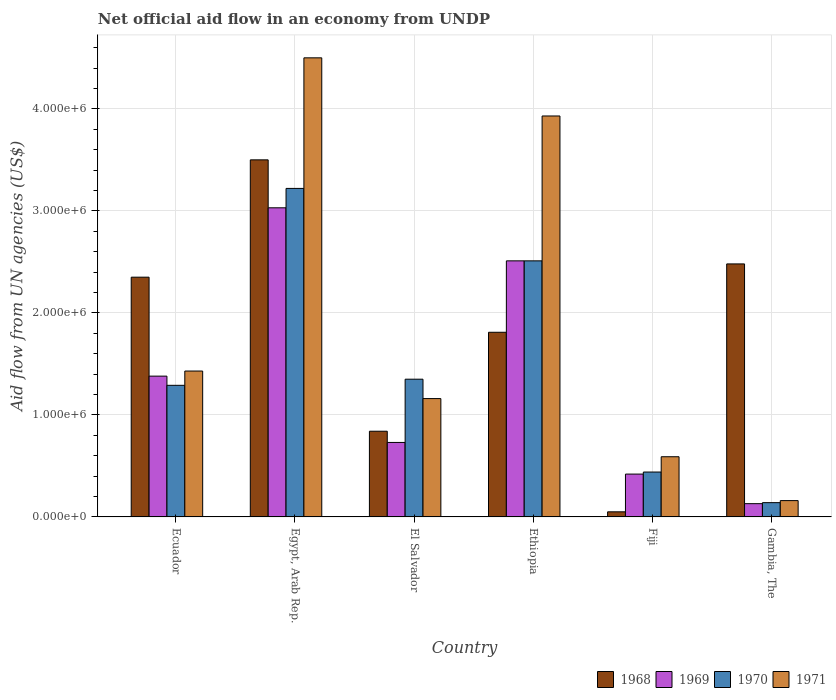How many different coloured bars are there?
Your answer should be compact. 4. How many groups of bars are there?
Keep it short and to the point. 6. Are the number of bars on each tick of the X-axis equal?
Keep it short and to the point. Yes. How many bars are there on the 1st tick from the left?
Keep it short and to the point. 4. What is the label of the 6th group of bars from the left?
Provide a short and direct response. Gambia, The. In how many cases, is the number of bars for a given country not equal to the number of legend labels?
Your answer should be compact. 0. What is the net official aid flow in 1970 in El Salvador?
Provide a succinct answer. 1.35e+06. Across all countries, what is the maximum net official aid flow in 1969?
Give a very brief answer. 3.03e+06. In which country was the net official aid flow in 1970 maximum?
Your response must be concise. Egypt, Arab Rep. In which country was the net official aid flow in 1969 minimum?
Keep it short and to the point. Gambia, The. What is the total net official aid flow in 1971 in the graph?
Your response must be concise. 1.18e+07. What is the difference between the net official aid flow in 1968 in Ecuador and that in El Salvador?
Offer a very short reply. 1.51e+06. What is the average net official aid flow in 1969 per country?
Provide a short and direct response. 1.37e+06. What is the difference between the net official aid flow of/in 1971 and net official aid flow of/in 1970 in Fiji?
Make the answer very short. 1.50e+05. In how many countries, is the net official aid flow in 1969 greater than 4000000 US$?
Make the answer very short. 0. What is the ratio of the net official aid flow in 1970 in El Salvador to that in Fiji?
Offer a terse response. 3.07. Is the net official aid flow in 1971 in Ecuador less than that in Gambia, The?
Give a very brief answer. No. What is the difference between the highest and the second highest net official aid flow in 1968?
Keep it short and to the point. 1.02e+06. What is the difference between the highest and the lowest net official aid flow in 1971?
Provide a succinct answer. 4.34e+06. In how many countries, is the net official aid flow in 1968 greater than the average net official aid flow in 1968 taken over all countries?
Provide a short and direct response. 3. Is the sum of the net official aid flow in 1969 in Ethiopia and Fiji greater than the maximum net official aid flow in 1968 across all countries?
Make the answer very short. No. Is it the case that in every country, the sum of the net official aid flow in 1968 and net official aid flow in 1970 is greater than the sum of net official aid flow in 1969 and net official aid flow in 1971?
Offer a very short reply. No. What does the 1st bar from the left in Gambia, The represents?
Offer a terse response. 1968. What does the 1st bar from the right in Ecuador represents?
Your answer should be very brief. 1971. Is it the case that in every country, the sum of the net official aid flow in 1968 and net official aid flow in 1969 is greater than the net official aid flow in 1970?
Make the answer very short. Yes. Does the graph contain grids?
Keep it short and to the point. Yes. What is the title of the graph?
Offer a very short reply. Net official aid flow in an economy from UNDP. What is the label or title of the X-axis?
Ensure brevity in your answer.  Country. What is the label or title of the Y-axis?
Provide a short and direct response. Aid flow from UN agencies (US$). What is the Aid flow from UN agencies (US$) of 1968 in Ecuador?
Ensure brevity in your answer.  2.35e+06. What is the Aid flow from UN agencies (US$) of 1969 in Ecuador?
Provide a succinct answer. 1.38e+06. What is the Aid flow from UN agencies (US$) of 1970 in Ecuador?
Offer a terse response. 1.29e+06. What is the Aid flow from UN agencies (US$) in 1971 in Ecuador?
Offer a very short reply. 1.43e+06. What is the Aid flow from UN agencies (US$) of 1968 in Egypt, Arab Rep.?
Your answer should be compact. 3.50e+06. What is the Aid flow from UN agencies (US$) of 1969 in Egypt, Arab Rep.?
Offer a very short reply. 3.03e+06. What is the Aid flow from UN agencies (US$) in 1970 in Egypt, Arab Rep.?
Your answer should be very brief. 3.22e+06. What is the Aid flow from UN agencies (US$) of 1971 in Egypt, Arab Rep.?
Offer a very short reply. 4.50e+06. What is the Aid flow from UN agencies (US$) in 1968 in El Salvador?
Offer a very short reply. 8.40e+05. What is the Aid flow from UN agencies (US$) in 1969 in El Salvador?
Keep it short and to the point. 7.30e+05. What is the Aid flow from UN agencies (US$) of 1970 in El Salvador?
Provide a short and direct response. 1.35e+06. What is the Aid flow from UN agencies (US$) of 1971 in El Salvador?
Your response must be concise. 1.16e+06. What is the Aid flow from UN agencies (US$) in 1968 in Ethiopia?
Ensure brevity in your answer.  1.81e+06. What is the Aid flow from UN agencies (US$) in 1969 in Ethiopia?
Provide a short and direct response. 2.51e+06. What is the Aid flow from UN agencies (US$) of 1970 in Ethiopia?
Make the answer very short. 2.51e+06. What is the Aid flow from UN agencies (US$) in 1971 in Ethiopia?
Offer a very short reply. 3.93e+06. What is the Aid flow from UN agencies (US$) of 1968 in Fiji?
Your answer should be compact. 5.00e+04. What is the Aid flow from UN agencies (US$) of 1969 in Fiji?
Offer a terse response. 4.20e+05. What is the Aid flow from UN agencies (US$) in 1971 in Fiji?
Offer a very short reply. 5.90e+05. What is the Aid flow from UN agencies (US$) of 1968 in Gambia, The?
Ensure brevity in your answer.  2.48e+06. What is the Aid flow from UN agencies (US$) in 1969 in Gambia, The?
Give a very brief answer. 1.30e+05. What is the Aid flow from UN agencies (US$) of 1970 in Gambia, The?
Offer a terse response. 1.40e+05. Across all countries, what is the maximum Aid flow from UN agencies (US$) in 1968?
Your answer should be compact. 3.50e+06. Across all countries, what is the maximum Aid flow from UN agencies (US$) of 1969?
Offer a very short reply. 3.03e+06. Across all countries, what is the maximum Aid flow from UN agencies (US$) of 1970?
Offer a terse response. 3.22e+06. Across all countries, what is the maximum Aid flow from UN agencies (US$) in 1971?
Give a very brief answer. 4.50e+06. Across all countries, what is the minimum Aid flow from UN agencies (US$) in 1968?
Your answer should be compact. 5.00e+04. Across all countries, what is the minimum Aid flow from UN agencies (US$) of 1970?
Your answer should be very brief. 1.40e+05. Across all countries, what is the minimum Aid flow from UN agencies (US$) in 1971?
Provide a short and direct response. 1.60e+05. What is the total Aid flow from UN agencies (US$) in 1968 in the graph?
Your answer should be very brief. 1.10e+07. What is the total Aid flow from UN agencies (US$) in 1969 in the graph?
Offer a very short reply. 8.20e+06. What is the total Aid flow from UN agencies (US$) in 1970 in the graph?
Your answer should be compact. 8.95e+06. What is the total Aid flow from UN agencies (US$) in 1971 in the graph?
Ensure brevity in your answer.  1.18e+07. What is the difference between the Aid flow from UN agencies (US$) in 1968 in Ecuador and that in Egypt, Arab Rep.?
Your answer should be compact. -1.15e+06. What is the difference between the Aid flow from UN agencies (US$) in 1969 in Ecuador and that in Egypt, Arab Rep.?
Ensure brevity in your answer.  -1.65e+06. What is the difference between the Aid flow from UN agencies (US$) of 1970 in Ecuador and that in Egypt, Arab Rep.?
Make the answer very short. -1.93e+06. What is the difference between the Aid flow from UN agencies (US$) in 1971 in Ecuador and that in Egypt, Arab Rep.?
Keep it short and to the point. -3.07e+06. What is the difference between the Aid flow from UN agencies (US$) in 1968 in Ecuador and that in El Salvador?
Give a very brief answer. 1.51e+06. What is the difference between the Aid flow from UN agencies (US$) in 1969 in Ecuador and that in El Salvador?
Offer a terse response. 6.50e+05. What is the difference between the Aid flow from UN agencies (US$) of 1970 in Ecuador and that in El Salvador?
Your answer should be very brief. -6.00e+04. What is the difference between the Aid flow from UN agencies (US$) of 1968 in Ecuador and that in Ethiopia?
Make the answer very short. 5.40e+05. What is the difference between the Aid flow from UN agencies (US$) of 1969 in Ecuador and that in Ethiopia?
Keep it short and to the point. -1.13e+06. What is the difference between the Aid flow from UN agencies (US$) of 1970 in Ecuador and that in Ethiopia?
Give a very brief answer. -1.22e+06. What is the difference between the Aid flow from UN agencies (US$) of 1971 in Ecuador and that in Ethiopia?
Offer a very short reply. -2.50e+06. What is the difference between the Aid flow from UN agencies (US$) of 1968 in Ecuador and that in Fiji?
Provide a short and direct response. 2.30e+06. What is the difference between the Aid flow from UN agencies (US$) of 1969 in Ecuador and that in Fiji?
Your answer should be compact. 9.60e+05. What is the difference between the Aid flow from UN agencies (US$) in 1970 in Ecuador and that in Fiji?
Your response must be concise. 8.50e+05. What is the difference between the Aid flow from UN agencies (US$) of 1971 in Ecuador and that in Fiji?
Offer a terse response. 8.40e+05. What is the difference between the Aid flow from UN agencies (US$) of 1969 in Ecuador and that in Gambia, The?
Your answer should be very brief. 1.25e+06. What is the difference between the Aid flow from UN agencies (US$) in 1970 in Ecuador and that in Gambia, The?
Provide a short and direct response. 1.15e+06. What is the difference between the Aid flow from UN agencies (US$) of 1971 in Ecuador and that in Gambia, The?
Make the answer very short. 1.27e+06. What is the difference between the Aid flow from UN agencies (US$) of 1968 in Egypt, Arab Rep. and that in El Salvador?
Your answer should be very brief. 2.66e+06. What is the difference between the Aid flow from UN agencies (US$) in 1969 in Egypt, Arab Rep. and that in El Salvador?
Provide a succinct answer. 2.30e+06. What is the difference between the Aid flow from UN agencies (US$) in 1970 in Egypt, Arab Rep. and that in El Salvador?
Keep it short and to the point. 1.87e+06. What is the difference between the Aid flow from UN agencies (US$) in 1971 in Egypt, Arab Rep. and that in El Salvador?
Offer a terse response. 3.34e+06. What is the difference between the Aid flow from UN agencies (US$) of 1968 in Egypt, Arab Rep. and that in Ethiopia?
Offer a very short reply. 1.69e+06. What is the difference between the Aid flow from UN agencies (US$) of 1969 in Egypt, Arab Rep. and that in Ethiopia?
Give a very brief answer. 5.20e+05. What is the difference between the Aid flow from UN agencies (US$) of 1970 in Egypt, Arab Rep. and that in Ethiopia?
Provide a short and direct response. 7.10e+05. What is the difference between the Aid flow from UN agencies (US$) in 1971 in Egypt, Arab Rep. and that in Ethiopia?
Provide a succinct answer. 5.70e+05. What is the difference between the Aid flow from UN agencies (US$) of 1968 in Egypt, Arab Rep. and that in Fiji?
Offer a terse response. 3.45e+06. What is the difference between the Aid flow from UN agencies (US$) of 1969 in Egypt, Arab Rep. and that in Fiji?
Offer a very short reply. 2.61e+06. What is the difference between the Aid flow from UN agencies (US$) in 1970 in Egypt, Arab Rep. and that in Fiji?
Your answer should be very brief. 2.78e+06. What is the difference between the Aid flow from UN agencies (US$) in 1971 in Egypt, Arab Rep. and that in Fiji?
Ensure brevity in your answer.  3.91e+06. What is the difference between the Aid flow from UN agencies (US$) of 1968 in Egypt, Arab Rep. and that in Gambia, The?
Keep it short and to the point. 1.02e+06. What is the difference between the Aid flow from UN agencies (US$) in 1969 in Egypt, Arab Rep. and that in Gambia, The?
Provide a short and direct response. 2.90e+06. What is the difference between the Aid flow from UN agencies (US$) in 1970 in Egypt, Arab Rep. and that in Gambia, The?
Keep it short and to the point. 3.08e+06. What is the difference between the Aid flow from UN agencies (US$) of 1971 in Egypt, Arab Rep. and that in Gambia, The?
Your answer should be compact. 4.34e+06. What is the difference between the Aid flow from UN agencies (US$) in 1968 in El Salvador and that in Ethiopia?
Give a very brief answer. -9.70e+05. What is the difference between the Aid flow from UN agencies (US$) of 1969 in El Salvador and that in Ethiopia?
Offer a terse response. -1.78e+06. What is the difference between the Aid flow from UN agencies (US$) in 1970 in El Salvador and that in Ethiopia?
Your answer should be compact. -1.16e+06. What is the difference between the Aid flow from UN agencies (US$) in 1971 in El Salvador and that in Ethiopia?
Your answer should be very brief. -2.77e+06. What is the difference between the Aid flow from UN agencies (US$) of 1968 in El Salvador and that in Fiji?
Provide a succinct answer. 7.90e+05. What is the difference between the Aid flow from UN agencies (US$) in 1969 in El Salvador and that in Fiji?
Make the answer very short. 3.10e+05. What is the difference between the Aid flow from UN agencies (US$) of 1970 in El Salvador and that in Fiji?
Give a very brief answer. 9.10e+05. What is the difference between the Aid flow from UN agencies (US$) of 1971 in El Salvador and that in Fiji?
Offer a very short reply. 5.70e+05. What is the difference between the Aid flow from UN agencies (US$) in 1968 in El Salvador and that in Gambia, The?
Your answer should be very brief. -1.64e+06. What is the difference between the Aid flow from UN agencies (US$) in 1969 in El Salvador and that in Gambia, The?
Provide a short and direct response. 6.00e+05. What is the difference between the Aid flow from UN agencies (US$) of 1970 in El Salvador and that in Gambia, The?
Provide a succinct answer. 1.21e+06. What is the difference between the Aid flow from UN agencies (US$) of 1968 in Ethiopia and that in Fiji?
Ensure brevity in your answer.  1.76e+06. What is the difference between the Aid flow from UN agencies (US$) in 1969 in Ethiopia and that in Fiji?
Offer a terse response. 2.09e+06. What is the difference between the Aid flow from UN agencies (US$) in 1970 in Ethiopia and that in Fiji?
Offer a very short reply. 2.07e+06. What is the difference between the Aid flow from UN agencies (US$) of 1971 in Ethiopia and that in Fiji?
Your answer should be compact. 3.34e+06. What is the difference between the Aid flow from UN agencies (US$) of 1968 in Ethiopia and that in Gambia, The?
Your response must be concise. -6.70e+05. What is the difference between the Aid flow from UN agencies (US$) in 1969 in Ethiopia and that in Gambia, The?
Give a very brief answer. 2.38e+06. What is the difference between the Aid flow from UN agencies (US$) in 1970 in Ethiopia and that in Gambia, The?
Provide a succinct answer. 2.37e+06. What is the difference between the Aid flow from UN agencies (US$) of 1971 in Ethiopia and that in Gambia, The?
Your answer should be very brief. 3.77e+06. What is the difference between the Aid flow from UN agencies (US$) in 1968 in Fiji and that in Gambia, The?
Your answer should be compact. -2.43e+06. What is the difference between the Aid flow from UN agencies (US$) in 1971 in Fiji and that in Gambia, The?
Keep it short and to the point. 4.30e+05. What is the difference between the Aid flow from UN agencies (US$) of 1968 in Ecuador and the Aid flow from UN agencies (US$) of 1969 in Egypt, Arab Rep.?
Your response must be concise. -6.80e+05. What is the difference between the Aid flow from UN agencies (US$) of 1968 in Ecuador and the Aid flow from UN agencies (US$) of 1970 in Egypt, Arab Rep.?
Your answer should be very brief. -8.70e+05. What is the difference between the Aid flow from UN agencies (US$) in 1968 in Ecuador and the Aid flow from UN agencies (US$) in 1971 in Egypt, Arab Rep.?
Provide a short and direct response. -2.15e+06. What is the difference between the Aid flow from UN agencies (US$) of 1969 in Ecuador and the Aid flow from UN agencies (US$) of 1970 in Egypt, Arab Rep.?
Keep it short and to the point. -1.84e+06. What is the difference between the Aid flow from UN agencies (US$) in 1969 in Ecuador and the Aid flow from UN agencies (US$) in 1971 in Egypt, Arab Rep.?
Your answer should be compact. -3.12e+06. What is the difference between the Aid flow from UN agencies (US$) of 1970 in Ecuador and the Aid flow from UN agencies (US$) of 1971 in Egypt, Arab Rep.?
Your answer should be compact. -3.21e+06. What is the difference between the Aid flow from UN agencies (US$) in 1968 in Ecuador and the Aid flow from UN agencies (US$) in 1969 in El Salvador?
Provide a short and direct response. 1.62e+06. What is the difference between the Aid flow from UN agencies (US$) of 1968 in Ecuador and the Aid flow from UN agencies (US$) of 1971 in El Salvador?
Keep it short and to the point. 1.19e+06. What is the difference between the Aid flow from UN agencies (US$) in 1969 in Ecuador and the Aid flow from UN agencies (US$) in 1971 in El Salvador?
Your answer should be compact. 2.20e+05. What is the difference between the Aid flow from UN agencies (US$) of 1970 in Ecuador and the Aid flow from UN agencies (US$) of 1971 in El Salvador?
Your answer should be very brief. 1.30e+05. What is the difference between the Aid flow from UN agencies (US$) of 1968 in Ecuador and the Aid flow from UN agencies (US$) of 1969 in Ethiopia?
Your answer should be compact. -1.60e+05. What is the difference between the Aid flow from UN agencies (US$) of 1968 in Ecuador and the Aid flow from UN agencies (US$) of 1971 in Ethiopia?
Provide a succinct answer. -1.58e+06. What is the difference between the Aid flow from UN agencies (US$) of 1969 in Ecuador and the Aid flow from UN agencies (US$) of 1970 in Ethiopia?
Provide a succinct answer. -1.13e+06. What is the difference between the Aid flow from UN agencies (US$) of 1969 in Ecuador and the Aid flow from UN agencies (US$) of 1971 in Ethiopia?
Make the answer very short. -2.55e+06. What is the difference between the Aid flow from UN agencies (US$) of 1970 in Ecuador and the Aid flow from UN agencies (US$) of 1971 in Ethiopia?
Provide a short and direct response. -2.64e+06. What is the difference between the Aid flow from UN agencies (US$) in 1968 in Ecuador and the Aid flow from UN agencies (US$) in 1969 in Fiji?
Provide a succinct answer. 1.93e+06. What is the difference between the Aid flow from UN agencies (US$) of 1968 in Ecuador and the Aid flow from UN agencies (US$) of 1970 in Fiji?
Your answer should be very brief. 1.91e+06. What is the difference between the Aid flow from UN agencies (US$) of 1968 in Ecuador and the Aid flow from UN agencies (US$) of 1971 in Fiji?
Your response must be concise. 1.76e+06. What is the difference between the Aid flow from UN agencies (US$) of 1969 in Ecuador and the Aid flow from UN agencies (US$) of 1970 in Fiji?
Your answer should be compact. 9.40e+05. What is the difference between the Aid flow from UN agencies (US$) of 1969 in Ecuador and the Aid flow from UN agencies (US$) of 1971 in Fiji?
Offer a terse response. 7.90e+05. What is the difference between the Aid flow from UN agencies (US$) of 1970 in Ecuador and the Aid flow from UN agencies (US$) of 1971 in Fiji?
Give a very brief answer. 7.00e+05. What is the difference between the Aid flow from UN agencies (US$) in 1968 in Ecuador and the Aid flow from UN agencies (US$) in 1969 in Gambia, The?
Provide a short and direct response. 2.22e+06. What is the difference between the Aid flow from UN agencies (US$) of 1968 in Ecuador and the Aid flow from UN agencies (US$) of 1970 in Gambia, The?
Give a very brief answer. 2.21e+06. What is the difference between the Aid flow from UN agencies (US$) in 1968 in Ecuador and the Aid flow from UN agencies (US$) in 1971 in Gambia, The?
Give a very brief answer. 2.19e+06. What is the difference between the Aid flow from UN agencies (US$) in 1969 in Ecuador and the Aid flow from UN agencies (US$) in 1970 in Gambia, The?
Provide a short and direct response. 1.24e+06. What is the difference between the Aid flow from UN agencies (US$) in 1969 in Ecuador and the Aid flow from UN agencies (US$) in 1971 in Gambia, The?
Provide a short and direct response. 1.22e+06. What is the difference between the Aid flow from UN agencies (US$) of 1970 in Ecuador and the Aid flow from UN agencies (US$) of 1971 in Gambia, The?
Provide a succinct answer. 1.13e+06. What is the difference between the Aid flow from UN agencies (US$) of 1968 in Egypt, Arab Rep. and the Aid flow from UN agencies (US$) of 1969 in El Salvador?
Provide a short and direct response. 2.77e+06. What is the difference between the Aid flow from UN agencies (US$) in 1968 in Egypt, Arab Rep. and the Aid flow from UN agencies (US$) in 1970 in El Salvador?
Give a very brief answer. 2.15e+06. What is the difference between the Aid flow from UN agencies (US$) in 1968 in Egypt, Arab Rep. and the Aid flow from UN agencies (US$) in 1971 in El Salvador?
Your answer should be compact. 2.34e+06. What is the difference between the Aid flow from UN agencies (US$) of 1969 in Egypt, Arab Rep. and the Aid flow from UN agencies (US$) of 1970 in El Salvador?
Offer a terse response. 1.68e+06. What is the difference between the Aid flow from UN agencies (US$) in 1969 in Egypt, Arab Rep. and the Aid flow from UN agencies (US$) in 1971 in El Salvador?
Your response must be concise. 1.87e+06. What is the difference between the Aid flow from UN agencies (US$) of 1970 in Egypt, Arab Rep. and the Aid flow from UN agencies (US$) of 1971 in El Salvador?
Your answer should be very brief. 2.06e+06. What is the difference between the Aid flow from UN agencies (US$) of 1968 in Egypt, Arab Rep. and the Aid flow from UN agencies (US$) of 1969 in Ethiopia?
Ensure brevity in your answer.  9.90e+05. What is the difference between the Aid flow from UN agencies (US$) in 1968 in Egypt, Arab Rep. and the Aid flow from UN agencies (US$) in 1970 in Ethiopia?
Keep it short and to the point. 9.90e+05. What is the difference between the Aid flow from UN agencies (US$) in 1968 in Egypt, Arab Rep. and the Aid flow from UN agencies (US$) in 1971 in Ethiopia?
Give a very brief answer. -4.30e+05. What is the difference between the Aid flow from UN agencies (US$) in 1969 in Egypt, Arab Rep. and the Aid flow from UN agencies (US$) in 1970 in Ethiopia?
Your answer should be compact. 5.20e+05. What is the difference between the Aid flow from UN agencies (US$) of 1969 in Egypt, Arab Rep. and the Aid flow from UN agencies (US$) of 1971 in Ethiopia?
Offer a terse response. -9.00e+05. What is the difference between the Aid flow from UN agencies (US$) in 1970 in Egypt, Arab Rep. and the Aid flow from UN agencies (US$) in 1971 in Ethiopia?
Ensure brevity in your answer.  -7.10e+05. What is the difference between the Aid flow from UN agencies (US$) of 1968 in Egypt, Arab Rep. and the Aid flow from UN agencies (US$) of 1969 in Fiji?
Keep it short and to the point. 3.08e+06. What is the difference between the Aid flow from UN agencies (US$) in 1968 in Egypt, Arab Rep. and the Aid flow from UN agencies (US$) in 1970 in Fiji?
Provide a short and direct response. 3.06e+06. What is the difference between the Aid flow from UN agencies (US$) of 1968 in Egypt, Arab Rep. and the Aid flow from UN agencies (US$) of 1971 in Fiji?
Your answer should be very brief. 2.91e+06. What is the difference between the Aid flow from UN agencies (US$) in 1969 in Egypt, Arab Rep. and the Aid flow from UN agencies (US$) in 1970 in Fiji?
Give a very brief answer. 2.59e+06. What is the difference between the Aid flow from UN agencies (US$) of 1969 in Egypt, Arab Rep. and the Aid flow from UN agencies (US$) of 1971 in Fiji?
Give a very brief answer. 2.44e+06. What is the difference between the Aid flow from UN agencies (US$) of 1970 in Egypt, Arab Rep. and the Aid flow from UN agencies (US$) of 1971 in Fiji?
Your answer should be very brief. 2.63e+06. What is the difference between the Aid flow from UN agencies (US$) in 1968 in Egypt, Arab Rep. and the Aid flow from UN agencies (US$) in 1969 in Gambia, The?
Give a very brief answer. 3.37e+06. What is the difference between the Aid flow from UN agencies (US$) of 1968 in Egypt, Arab Rep. and the Aid flow from UN agencies (US$) of 1970 in Gambia, The?
Offer a terse response. 3.36e+06. What is the difference between the Aid flow from UN agencies (US$) in 1968 in Egypt, Arab Rep. and the Aid flow from UN agencies (US$) in 1971 in Gambia, The?
Offer a terse response. 3.34e+06. What is the difference between the Aid flow from UN agencies (US$) in 1969 in Egypt, Arab Rep. and the Aid flow from UN agencies (US$) in 1970 in Gambia, The?
Your answer should be very brief. 2.89e+06. What is the difference between the Aid flow from UN agencies (US$) of 1969 in Egypt, Arab Rep. and the Aid flow from UN agencies (US$) of 1971 in Gambia, The?
Provide a short and direct response. 2.87e+06. What is the difference between the Aid flow from UN agencies (US$) in 1970 in Egypt, Arab Rep. and the Aid flow from UN agencies (US$) in 1971 in Gambia, The?
Your response must be concise. 3.06e+06. What is the difference between the Aid flow from UN agencies (US$) of 1968 in El Salvador and the Aid flow from UN agencies (US$) of 1969 in Ethiopia?
Offer a terse response. -1.67e+06. What is the difference between the Aid flow from UN agencies (US$) of 1968 in El Salvador and the Aid flow from UN agencies (US$) of 1970 in Ethiopia?
Give a very brief answer. -1.67e+06. What is the difference between the Aid flow from UN agencies (US$) of 1968 in El Salvador and the Aid flow from UN agencies (US$) of 1971 in Ethiopia?
Your answer should be very brief. -3.09e+06. What is the difference between the Aid flow from UN agencies (US$) of 1969 in El Salvador and the Aid flow from UN agencies (US$) of 1970 in Ethiopia?
Give a very brief answer. -1.78e+06. What is the difference between the Aid flow from UN agencies (US$) in 1969 in El Salvador and the Aid flow from UN agencies (US$) in 1971 in Ethiopia?
Keep it short and to the point. -3.20e+06. What is the difference between the Aid flow from UN agencies (US$) in 1970 in El Salvador and the Aid flow from UN agencies (US$) in 1971 in Ethiopia?
Offer a very short reply. -2.58e+06. What is the difference between the Aid flow from UN agencies (US$) of 1968 in El Salvador and the Aid flow from UN agencies (US$) of 1970 in Fiji?
Give a very brief answer. 4.00e+05. What is the difference between the Aid flow from UN agencies (US$) in 1969 in El Salvador and the Aid flow from UN agencies (US$) in 1971 in Fiji?
Provide a short and direct response. 1.40e+05. What is the difference between the Aid flow from UN agencies (US$) of 1970 in El Salvador and the Aid flow from UN agencies (US$) of 1971 in Fiji?
Provide a succinct answer. 7.60e+05. What is the difference between the Aid flow from UN agencies (US$) of 1968 in El Salvador and the Aid flow from UN agencies (US$) of 1969 in Gambia, The?
Keep it short and to the point. 7.10e+05. What is the difference between the Aid flow from UN agencies (US$) in 1968 in El Salvador and the Aid flow from UN agencies (US$) in 1971 in Gambia, The?
Offer a very short reply. 6.80e+05. What is the difference between the Aid flow from UN agencies (US$) in 1969 in El Salvador and the Aid flow from UN agencies (US$) in 1970 in Gambia, The?
Offer a terse response. 5.90e+05. What is the difference between the Aid flow from UN agencies (US$) in 1969 in El Salvador and the Aid flow from UN agencies (US$) in 1971 in Gambia, The?
Your answer should be compact. 5.70e+05. What is the difference between the Aid flow from UN agencies (US$) of 1970 in El Salvador and the Aid flow from UN agencies (US$) of 1971 in Gambia, The?
Keep it short and to the point. 1.19e+06. What is the difference between the Aid flow from UN agencies (US$) of 1968 in Ethiopia and the Aid flow from UN agencies (US$) of 1969 in Fiji?
Ensure brevity in your answer.  1.39e+06. What is the difference between the Aid flow from UN agencies (US$) in 1968 in Ethiopia and the Aid flow from UN agencies (US$) in 1970 in Fiji?
Your answer should be compact. 1.37e+06. What is the difference between the Aid flow from UN agencies (US$) in 1968 in Ethiopia and the Aid flow from UN agencies (US$) in 1971 in Fiji?
Provide a succinct answer. 1.22e+06. What is the difference between the Aid flow from UN agencies (US$) in 1969 in Ethiopia and the Aid flow from UN agencies (US$) in 1970 in Fiji?
Ensure brevity in your answer.  2.07e+06. What is the difference between the Aid flow from UN agencies (US$) in 1969 in Ethiopia and the Aid flow from UN agencies (US$) in 1971 in Fiji?
Provide a short and direct response. 1.92e+06. What is the difference between the Aid flow from UN agencies (US$) in 1970 in Ethiopia and the Aid flow from UN agencies (US$) in 1971 in Fiji?
Ensure brevity in your answer.  1.92e+06. What is the difference between the Aid flow from UN agencies (US$) of 1968 in Ethiopia and the Aid flow from UN agencies (US$) of 1969 in Gambia, The?
Your answer should be compact. 1.68e+06. What is the difference between the Aid flow from UN agencies (US$) in 1968 in Ethiopia and the Aid flow from UN agencies (US$) in 1970 in Gambia, The?
Your response must be concise. 1.67e+06. What is the difference between the Aid flow from UN agencies (US$) of 1968 in Ethiopia and the Aid flow from UN agencies (US$) of 1971 in Gambia, The?
Offer a terse response. 1.65e+06. What is the difference between the Aid flow from UN agencies (US$) in 1969 in Ethiopia and the Aid flow from UN agencies (US$) in 1970 in Gambia, The?
Give a very brief answer. 2.37e+06. What is the difference between the Aid flow from UN agencies (US$) of 1969 in Ethiopia and the Aid flow from UN agencies (US$) of 1971 in Gambia, The?
Make the answer very short. 2.35e+06. What is the difference between the Aid flow from UN agencies (US$) of 1970 in Ethiopia and the Aid flow from UN agencies (US$) of 1971 in Gambia, The?
Give a very brief answer. 2.35e+06. What is the difference between the Aid flow from UN agencies (US$) of 1968 in Fiji and the Aid flow from UN agencies (US$) of 1971 in Gambia, The?
Provide a succinct answer. -1.10e+05. What is the difference between the Aid flow from UN agencies (US$) in 1969 in Fiji and the Aid flow from UN agencies (US$) in 1971 in Gambia, The?
Give a very brief answer. 2.60e+05. What is the difference between the Aid flow from UN agencies (US$) of 1970 in Fiji and the Aid flow from UN agencies (US$) of 1971 in Gambia, The?
Your answer should be compact. 2.80e+05. What is the average Aid flow from UN agencies (US$) in 1968 per country?
Give a very brief answer. 1.84e+06. What is the average Aid flow from UN agencies (US$) in 1969 per country?
Your answer should be compact. 1.37e+06. What is the average Aid flow from UN agencies (US$) of 1970 per country?
Your answer should be very brief. 1.49e+06. What is the average Aid flow from UN agencies (US$) in 1971 per country?
Offer a terse response. 1.96e+06. What is the difference between the Aid flow from UN agencies (US$) of 1968 and Aid flow from UN agencies (US$) of 1969 in Ecuador?
Your answer should be very brief. 9.70e+05. What is the difference between the Aid flow from UN agencies (US$) of 1968 and Aid flow from UN agencies (US$) of 1970 in Ecuador?
Your answer should be very brief. 1.06e+06. What is the difference between the Aid flow from UN agencies (US$) of 1968 and Aid flow from UN agencies (US$) of 1971 in Ecuador?
Ensure brevity in your answer.  9.20e+05. What is the difference between the Aid flow from UN agencies (US$) in 1970 and Aid flow from UN agencies (US$) in 1971 in Ecuador?
Your answer should be very brief. -1.40e+05. What is the difference between the Aid flow from UN agencies (US$) of 1968 and Aid flow from UN agencies (US$) of 1969 in Egypt, Arab Rep.?
Ensure brevity in your answer.  4.70e+05. What is the difference between the Aid flow from UN agencies (US$) in 1968 and Aid flow from UN agencies (US$) in 1970 in Egypt, Arab Rep.?
Make the answer very short. 2.80e+05. What is the difference between the Aid flow from UN agencies (US$) of 1968 and Aid flow from UN agencies (US$) of 1971 in Egypt, Arab Rep.?
Give a very brief answer. -1.00e+06. What is the difference between the Aid flow from UN agencies (US$) of 1969 and Aid flow from UN agencies (US$) of 1971 in Egypt, Arab Rep.?
Make the answer very short. -1.47e+06. What is the difference between the Aid flow from UN agencies (US$) in 1970 and Aid flow from UN agencies (US$) in 1971 in Egypt, Arab Rep.?
Give a very brief answer. -1.28e+06. What is the difference between the Aid flow from UN agencies (US$) in 1968 and Aid flow from UN agencies (US$) in 1969 in El Salvador?
Keep it short and to the point. 1.10e+05. What is the difference between the Aid flow from UN agencies (US$) of 1968 and Aid flow from UN agencies (US$) of 1970 in El Salvador?
Your response must be concise. -5.10e+05. What is the difference between the Aid flow from UN agencies (US$) of 1968 and Aid flow from UN agencies (US$) of 1971 in El Salvador?
Your answer should be very brief. -3.20e+05. What is the difference between the Aid flow from UN agencies (US$) in 1969 and Aid flow from UN agencies (US$) in 1970 in El Salvador?
Provide a short and direct response. -6.20e+05. What is the difference between the Aid flow from UN agencies (US$) in 1969 and Aid flow from UN agencies (US$) in 1971 in El Salvador?
Your answer should be very brief. -4.30e+05. What is the difference between the Aid flow from UN agencies (US$) in 1968 and Aid flow from UN agencies (US$) in 1969 in Ethiopia?
Offer a terse response. -7.00e+05. What is the difference between the Aid flow from UN agencies (US$) in 1968 and Aid flow from UN agencies (US$) in 1970 in Ethiopia?
Provide a succinct answer. -7.00e+05. What is the difference between the Aid flow from UN agencies (US$) in 1968 and Aid flow from UN agencies (US$) in 1971 in Ethiopia?
Offer a terse response. -2.12e+06. What is the difference between the Aid flow from UN agencies (US$) in 1969 and Aid flow from UN agencies (US$) in 1971 in Ethiopia?
Provide a succinct answer. -1.42e+06. What is the difference between the Aid flow from UN agencies (US$) of 1970 and Aid flow from UN agencies (US$) of 1971 in Ethiopia?
Offer a very short reply. -1.42e+06. What is the difference between the Aid flow from UN agencies (US$) in 1968 and Aid flow from UN agencies (US$) in 1969 in Fiji?
Make the answer very short. -3.70e+05. What is the difference between the Aid flow from UN agencies (US$) of 1968 and Aid flow from UN agencies (US$) of 1970 in Fiji?
Give a very brief answer. -3.90e+05. What is the difference between the Aid flow from UN agencies (US$) of 1968 and Aid flow from UN agencies (US$) of 1971 in Fiji?
Provide a succinct answer. -5.40e+05. What is the difference between the Aid flow from UN agencies (US$) in 1969 and Aid flow from UN agencies (US$) in 1971 in Fiji?
Give a very brief answer. -1.70e+05. What is the difference between the Aid flow from UN agencies (US$) in 1968 and Aid flow from UN agencies (US$) in 1969 in Gambia, The?
Keep it short and to the point. 2.35e+06. What is the difference between the Aid flow from UN agencies (US$) in 1968 and Aid flow from UN agencies (US$) in 1970 in Gambia, The?
Offer a very short reply. 2.34e+06. What is the difference between the Aid flow from UN agencies (US$) in 1968 and Aid flow from UN agencies (US$) in 1971 in Gambia, The?
Provide a succinct answer. 2.32e+06. What is the difference between the Aid flow from UN agencies (US$) in 1969 and Aid flow from UN agencies (US$) in 1971 in Gambia, The?
Your answer should be compact. -3.00e+04. What is the difference between the Aid flow from UN agencies (US$) in 1970 and Aid flow from UN agencies (US$) in 1971 in Gambia, The?
Your answer should be very brief. -2.00e+04. What is the ratio of the Aid flow from UN agencies (US$) of 1968 in Ecuador to that in Egypt, Arab Rep.?
Keep it short and to the point. 0.67. What is the ratio of the Aid flow from UN agencies (US$) in 1969 in Ecuador to that in Egypt, Arab Rep.?
Your response must be concise. 0.46. What is the ratio of the Aid flow from UN agencies (US$) of 1970 in Ecuador to that in Egypt, Arab Rep.?
Give a very brief answer. 0.4. What is the ratio of the Aid flow from UN agencies (US$) in 1971 in Ecuador to that in Egypt, Arab Rep.?
Offer a terse response. 0.32. What is the ratio of the Aid flow from UN agencies (US$) of 1968 in Ecuador to that in El Salvador?
Provide a succinct answer. 2.8. What is the ratio of the Aid flow from UN agencies (US$) in 1969 in Ecuador to that in El Salvador?
Make the answer very short. 1.89. What is the ratio of the Aid flow from UN agencies (US$) of 1970 in Ecuador to that in El Salvador?
Provide a short and direct response. 0.96. What is the ratio of the Aid flow from UN agencies (US$) in 1971 in Ecuador to that in El Salvador?
Give a very brief answer. 1.23. What is the ratio of the Aid flow from UN agencies (US$) in 1968 in Ecuador to that in Ethiopia?
Ensure brevity in your answer.  1.3. What is the ratio of the Aid flow from UN agencies (US$) of 1969 in Ecuador to that in Ethiopia?
Your answer should be very brief. 0.55. What is the ratio of the Aid flow from UN agencies (US$) of 1970 in Ecuador to that in Ethiopia?
Your answer should be compact. 0.51. What is the ratio of the Aid flow from UN agencies (US$) of 1971 in Ecuador to that in Ethiopia?
Your answer should be very brief. 0.36. What is the ratio of the Aid flow from UN agencies (US$) of 1968 in Ecuador to that in Fiji?
Offer a very short reply. 47. What is the ratio of the Aid flow from UN agencies (US$) of 1969 in Ecuador to that in Fiji?
Keep it short and to the point. 3.29. What is the ratio of the Aid flow from UN agencies (US$) in 1970 in Ecuador to that in Fiji?
Your answer should be very brief. 2.93. What is the ratio of the Aid flow from UN agencies (US$) in 1971 in Ecuador to that in Fiji?
Your answer should be compact. 2.42. What is the ratio of the Aid flow from UN agencies (US$) in 1968 in Ecuador to that in Gambia, The?
Keep it short and to the point. 0.95. What is the ratio of the Aid flow from UN agencies (US$) in 1969 in Ecuador to that in Gambia, The?
Make the answer very short. 10.62. What is the ratio of the Aid flow from UN agencies (US$) of 1970 in Ecuador to that in Gambia, The?
Ensure brevity in your answer.  9.21. What is the ratio of the Aid flow from UN agencies (US$) in 1971 in Ecuador to that in Gambia, The?
Give a very brief answer. 8.94. What is the ratio of the Aid flow from UN agencies (US$) of 1968 in Egypt, Arab Rep. to that in El Salvador?
Provide a short and direct response. 4.17. What is the ratio of the Aid flow from UN agencies (US$) in 1969 in Egypt, Arab Rep. to that in El Salvador?
Your response must be concise. 4.15. What is the ratio of the Aid flow from UN agencies (US$) of 1970 in Egypt, Arab Rep. to that in El Salvador?
Your answer should be very brief. 2.39. What is the ratio of the Aid flow from UN agencies (US$) of 1971 in Egypt, Arab Rep. to that in El Salvador?
Make the answer very short. 3.88. What is the ratio of the Aid flow from UN agencies (US$) in 1968 in Egypt, Arab Rep. to that in Ethiopia?
Give a very brief answer. 1.93. What is the ratio of the Aid flow from UN agencies (US$) in 1969 in Egypt, Arab Rep. to that in Ethiopia?
Give a very brief answer. 1.21. What is the ratio of the Aid flow from UN agencies (US$) in 1970 in Egypt, Arab Rep. to that in Ethiopia?
Ensure brevity in your answer.  1.28. What is the ratio of the Aid flow from UN agencies (US$) of 1971 in Egypt, Arab Rep. to that in Ethiopia?
Give a very brief answer. 1.15. What is the ratio of the Aid flow from UN agencies (US$) of 1969 in Egypt, Arab Rep. to that in Fiji?
Provide a short and direct response. 7.21. What is the ratio of the Aid flow from UN agencies (US$) in 1970 in Egypt, Arab Rep. to that in Fiji?
Offer a terse response. 7.32. What is the ratio of the Aid flow from UN agencies (US$) in 1971 in Egypt, Arab Rep. to that in Fiji?
Your answer should be very brief. 7.63. What is the ratio of the Aid flow from UN agencies (US$) of 1968 in Egypt, Arab Rep. to that in Gambia, The?
Give a very brief answer. 1.41. What is the ratio of the Aid flow from UN agencies (US$) in 1969 in Egypt, Arab Rep. to that in Gambia, The?
Make the answer very short. 23.31. What is the ratio of the Aid flow from UN agencies (US$) in 1971 in Egypt, Arab Rep. to that in Gambia, The?
Provide a short and direct response. 28.12. What is the ratio of the Aid flow from UN agencies (US$) in 1968 in El Salvador to that in Ethiopia?
Provide a succinct answer. 0.46. What is the ratio of the Aid flow from UN agencies (US$) in 1969 in El Salvador to that in Ethiopia?
Provide a succinct answer. 0.29. What is the ratio of the Aid flow from UN agencies (US$) of 1970 in El Salvador to that in Ethiopia?
Ensure brevity in your answer.  0.54. What is the ratio of the Aid flow from UN agencies (US$) of 1971 in El Salvador to that in Ethiopia?
Make the answer very short. 0.3. What is the ratio of the Aid flow from UN agencies (US$) in 1968 in El Salvador to that in Fiji?
Your response must be concise. 16.8. What is the ratio of the Aid flow from UN agencies (US$) of 1969 in El Salvador to that in Fiji?
Ensure brevity in your answer.  1.74. What is the ratio of the Aid flow from UN agencies (US$) in 1970 in El Salvador to that in Fiji?
Make the answer very short. 3.07. What is the ratio of the Aid flow from UN agencies (US$) of 1971 in El Salvador to that in Fiji?
Provide a short and direct response. 1.97. What is the ratio of the Aid flow from UN agencies (US$) of 1968 in El Salvador to that in Gambia, The?
Your answer should be compact. 0.34. What is the ratio of the Aid flow from UN agencies (US$) in 1969 in El Salvador to that in Gambia, The?
Your answer should be very brief. 5.62. What is the ratio of the Aid flow from UN agencies (US$) in 1970 in El Salvador to that in Gambia, The?
Offer a very short reply. 9.64. What is the ratio of the Aid flow from UN agencies (US$) of 1971 in El Salvador to that in Gambia, The?
Your answer should be very brief. 7.25. What is the ratio of the Aid flow from UN agencies (US$) of 1968 in Ethiopia to that in Fiji?
Your answer should be compact. 36.2. What is the ratio of the Aid flow from UN agencies (US$) of 1969 in Ethiopia to that in Fiji?
Provide a succinct answer. 5.98. What is the ratio of the Aid flow from UN agencies (US$) in 1970 in Ethiopia to that in Fiji?
Your answer should be very brief. 5.7. What is the ratio of the Aid flow from UN agencies (US$) in 1971 in Ethiopia to that in Fiji?
Keep it short and to the point. 6.66. What is the ratio of the Aid flow from UN agencies (US$) in 1968 in Ethiopia to that in Gambia, The?
Offer a very short reply. 0.73. What is the ratio of the Aid flow from UN agencies (US$) of 1969 in Ethiopia to that in Gambia, The?
Your response must be concise. 19.31. What is the ratio of the Aid flow from UN agencies (US$) in 1970 in Ethiopia to that in Gambia, The?
Offer a terse response. 17.93. What is the ratio of the Aid flow from UN agencies (US$) of 1971 in Ethiopia to that in Gambia, The?
Keep it short and to the point. 24.56. What is the ratio of the Aid flow from UN agencies (US$) of 1968 in Fiji to that in Gambia, The?
Your answer should be very brief. 0.02. What is the ratio of the Aid flow from UN agencies (US$) of 1969 in Fiji to that in Gambia, The?
Offer a terse response. 3.23. What is the ratio of the Aid flow from UN agencies (US$) in 1970 in Fiji to that in Gambia, The?
Keep it short and to the point. 3.14. What is the ratio of the Aid flow from UN agencies (US$) in 1971 in Fiji to that in Gambia, The?
Provide a succinct answer. 3.69. What is the difference between the highest and the second highest Aid flow from UN agencies (US$) of 1968?
Give a very brief answer. 1.02e+06. What is the difference between the highest and the second highest Aid flow from UN agencies (US$) of 1969?
Make the answer very short. 5.20e+05. What is the difference between the highest and the second highest Aid flow from UN agencies (US$) of 1970?
Ensure brevity in your answer.  7.10e+05. What is the difference between the highest and the second highest Aid flow from UN agencies (US$) of 1971?
Offer a terse response. 5.70e+05. What is the difference between the highest and the lowest Aid flow from UN agencies (US$) in 1968?
Make the answer very short. 3.45e+06. What is the difference between the highest and the lowest Aid flow from UN agencies (US$) of 1969?
Give a very brief answer. 2.90e+06. What is the difference between the highest and the lowest Aid flow from UN agencies (US$) in 1970?
Offer a terse response. 3.08e+06. What is the difference between the highest and the lowest Aid flow from UN agencies (US$) of 1971?
Your answer should be compact. 4.34e+06. 